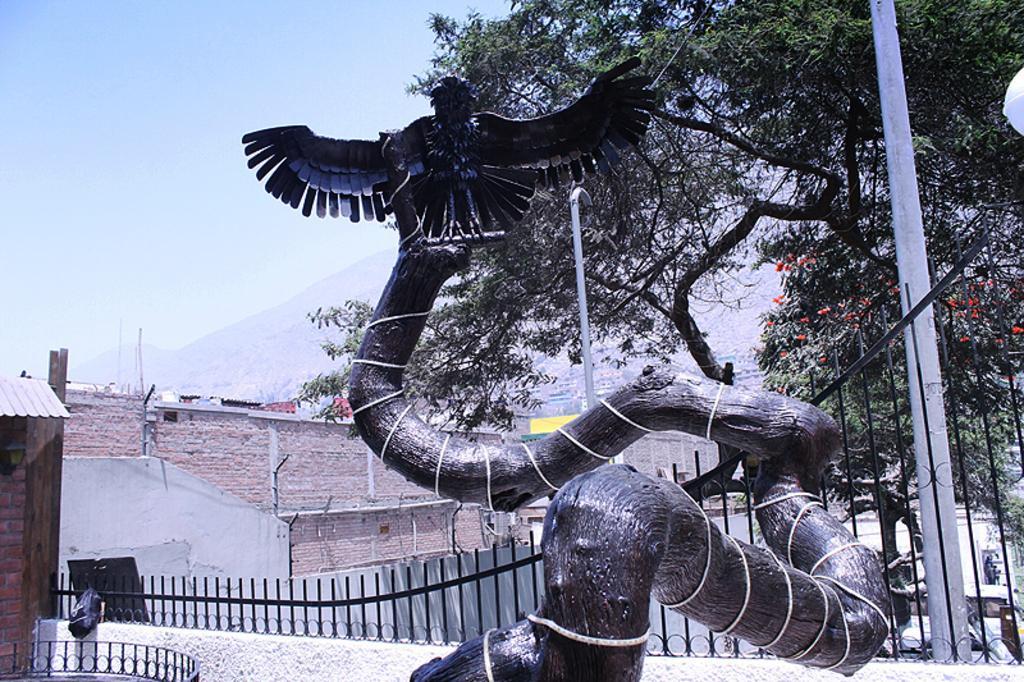In one or two sentences, can you explain what this image depicts? In this image there is a statue. Behind there is a fence on the wall. Right side there is a pole. Behind there are few trees. Behind there are few buildings. Behind there is a hill. Top of the image there is sky. 